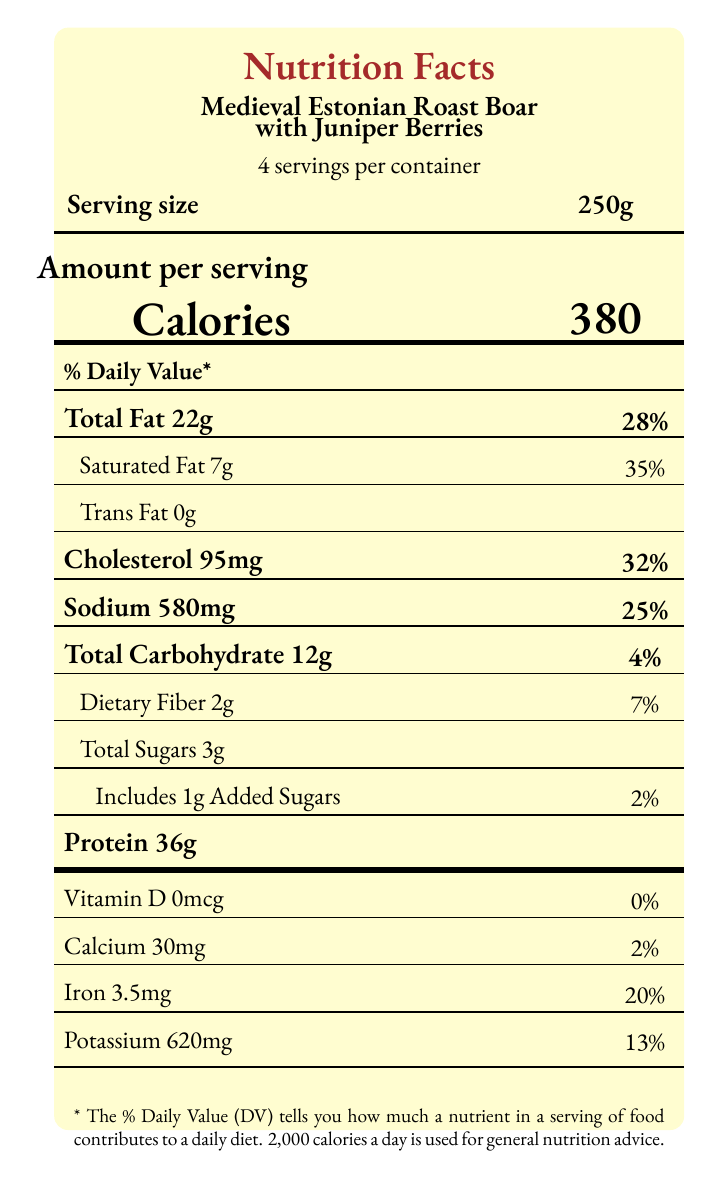What is the serving size of the dish? The serving size is explicitly mentioned in the document as "250g".
Answer: 250g How many servings are contained in the package? The document states "4 servings per container".
Answer: 4 servings What is the total calorie content per serving? The document lists the calories per serving as 380.
Answer: 380 calories How many grams of total fat does one serving contain? The total fat content per serving is clearly listed as "22g".
Answer: 22g What percentage of the daily value is the saturated fat per serving? The document indicates that the saturated fat content per serving is 7g, accounting for 35% of the daily value.
Answer: 35% What is the amount of added sugars in one serving? The document states that each serving includes 1g of added sugars.
Answer: 1g Which nutrient has the highest daily value percentage in this dish? A. Sodium B. Protein C. Saturated Fat D. Cholesterol Saturated fat has a daily value percentage of 35%, which is higher than any other nutrient listed in the document.
Answer: C. Saturated Fat Which of the following is NOT a key ingredient in the dish? A. Wild boar meat B. Juniper berries C. Barley D. Olive oil The document lists wild boar meat, juniper berries, barley, root vegetables, and herbs as key ingredients, but not olive oil.
Answer: D. Olive oil Is there any trans fat in the dish? The document states that there are 0g of trans fat per serving.
Answer: No Summarize the main idea of this document The document provides detailed nutritional information for one serving of "Medieval Estonian Roast Boar with Juniper Berries" and notes that the dish was inspired by 13th-century Estonian feasts. It also mentions historical context and modern adaptations made to improve nutritional balance and food safety.
Answer: The document is a Nutrition Facts Label for a recreated medieval Estonian dish, including its nutritional breakdown, key ingredients, historical context, and modern adaptations. How many grams of total carbohydrates are in a serving? The document states that there are 12g of total carbohydrates per serving.
Answer: 12g What changes were made to the original medieval recipe for modern consumption? The document lists these three modern adaptations for the recreated dish.
Answer: Reduced salt content, added vegetables, used modern cooking techniques What is the source of protein in this dish? The main source of protein in the dish, as specified in the key ingredients, is wild boar meat.
Answer: Wild boar meat Describe briefly the visual appearance of the Nutrition Facts Label. The document describes a visually styled nutrition label with specific colors and fonts, framing information about the dish's servings, calories, and nutrient breakdown.
Answer: The label is parchment-colored with medieval red text, framed in a rectangular, rounded-corner format. It details nutritional information, serving sizes, and daily value percentages. What is the percentage of daily calcium provided by one serving of the dish? The document indicates that one serving contains 30mg of calcium, which is 2% of the daily value.
Answer: 2% Can the amount of vitamin C in the dish be determined from the document? The document does not provide any information about the vitamin C content in the dish.
Answer: Not enough information 